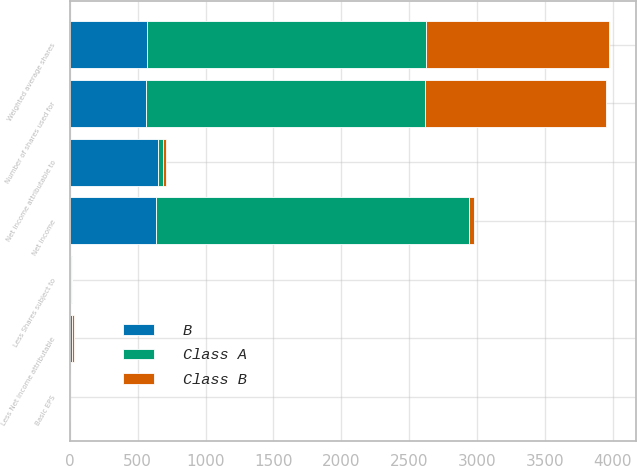Convert chart to OTSL. <chart><loc_0><loc_0><loc_500><loc_500><stacked_bar_chart><ecel><fcel>Net income<fcel>Less Net income attributable<fcel>Net income attributable to<fcel>Weighted average shares<fcel>Less Shares subject to<fcel>Number of shares used for<fcel>Basic EPS<nl><fcel>Class A<fcel>2308<fcel>12<fcel>35<fcel>2059<fcel>6<fcel>2053<fcel>1.12<nl><fcel>B<fcel>632<fcel>3<fcel>652<fcel>568<fcel>7<fcel>561<fcel>1.12<nl><fcel>Class B<fcel>35<fcel>14<fcel>22<fcel>1344<fcel>5<fcel>1339<fcel>0.02<nl></chart> 